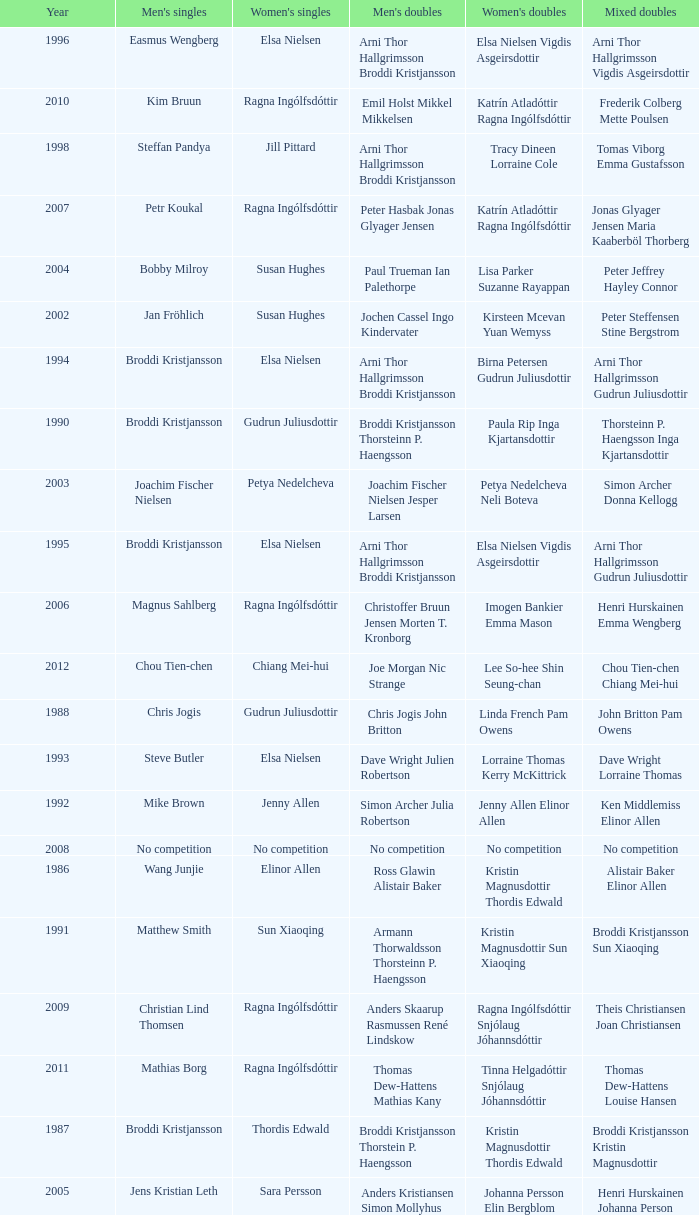In which women's doubles did Wang Junjie play men's singles? Kristin Magnusdottir Thordis Edwald. 